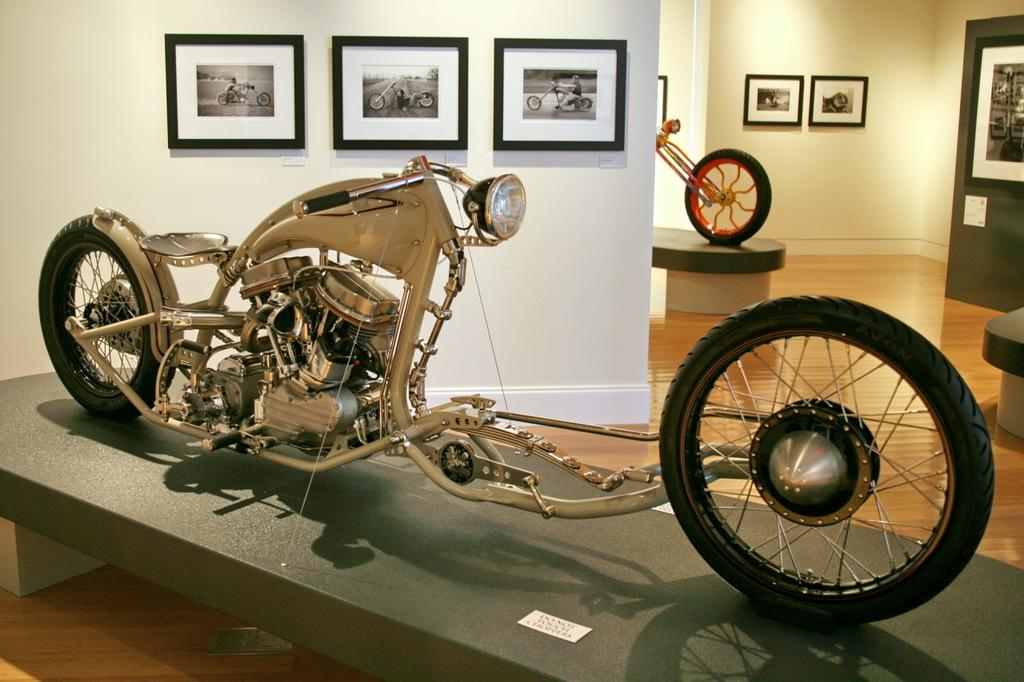What is the main piece of furniture in the image? There is a table in the image. Where is the table located? The table is on the floor. What is placed on top of the table? There is a motorcycle on the table. What type of architectural feature can be seen in the image? There is a wall and a door in the image. What is hanging on the wall? There is a photo frame on the wall. What type of prose can be seen written on the wall in the image? There is no prose visible on the wall in the image. How many cushions are placed on the motorcycle in the image? There are no cushions present in the image; it features a motorcycle on a table. 